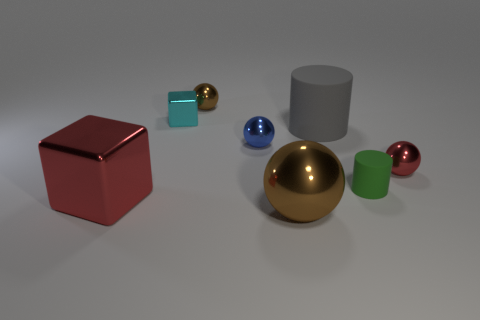Add 1 tiny metallic balls. How many objects exist? 9 Subtract all blocks. How many objects are left? 6 Subtract all purple balls. Subtract all small green things. How many objects are left? 7 Add 1 rubber cylinders. How many rubber cylinders are left? 3 Add 1 brown objects. How many brown objects exist? 3 Subtract 0 purple cubes. How many objects are left? 8 